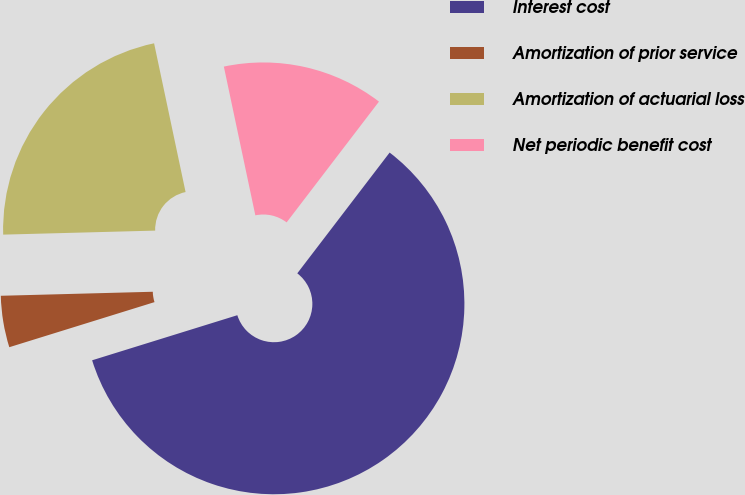Convert chart. <chart><loc_0><loc_0><loc_500><loc_500><pie_chart><fcel>Interest cost<fcel>Amortization of prior service<fcel>Amortization of actuarial loss<fcel>Net periodic benefit cost<nl><fcel>59.82%<fcel>4.37%<fcel>22.1%<fcel>13.71%<nl></chart> 